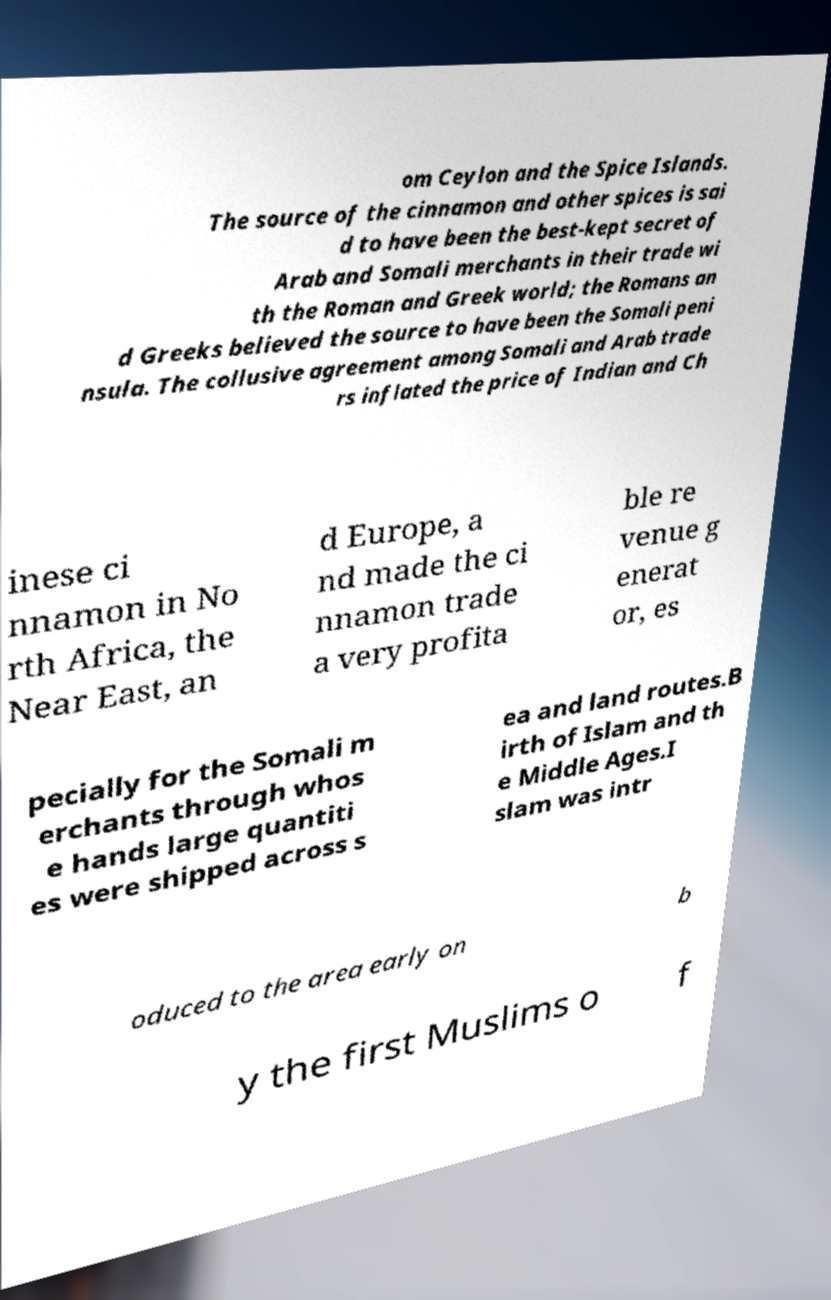Please identify and transcribe the text found in this image. om Ceylon and the Spice Islands. The source of the cinnamon and other spices is sai d to have been the best-kept secret of Arab and Somali merchants in their trade wi th the Roman and Greek world; the Romans an d Greeks believed the source to have been the Somali peni nsula. The collusive agreement among Somali and Arab trade rs inflated the price of Indian and Ch inese ci nnamon in No rth Africa, the Near East, an d Europe, a nd made the ci nnamon trade a very profita ble re venue g enerat or, es pecially for the Somali m erchants through whos e hands large quantiti es were shipped across s ea and land routes.B irth of Islam and th e Middle Ages.I slam was intr oduced to the area early on b y the first Muslims o f 